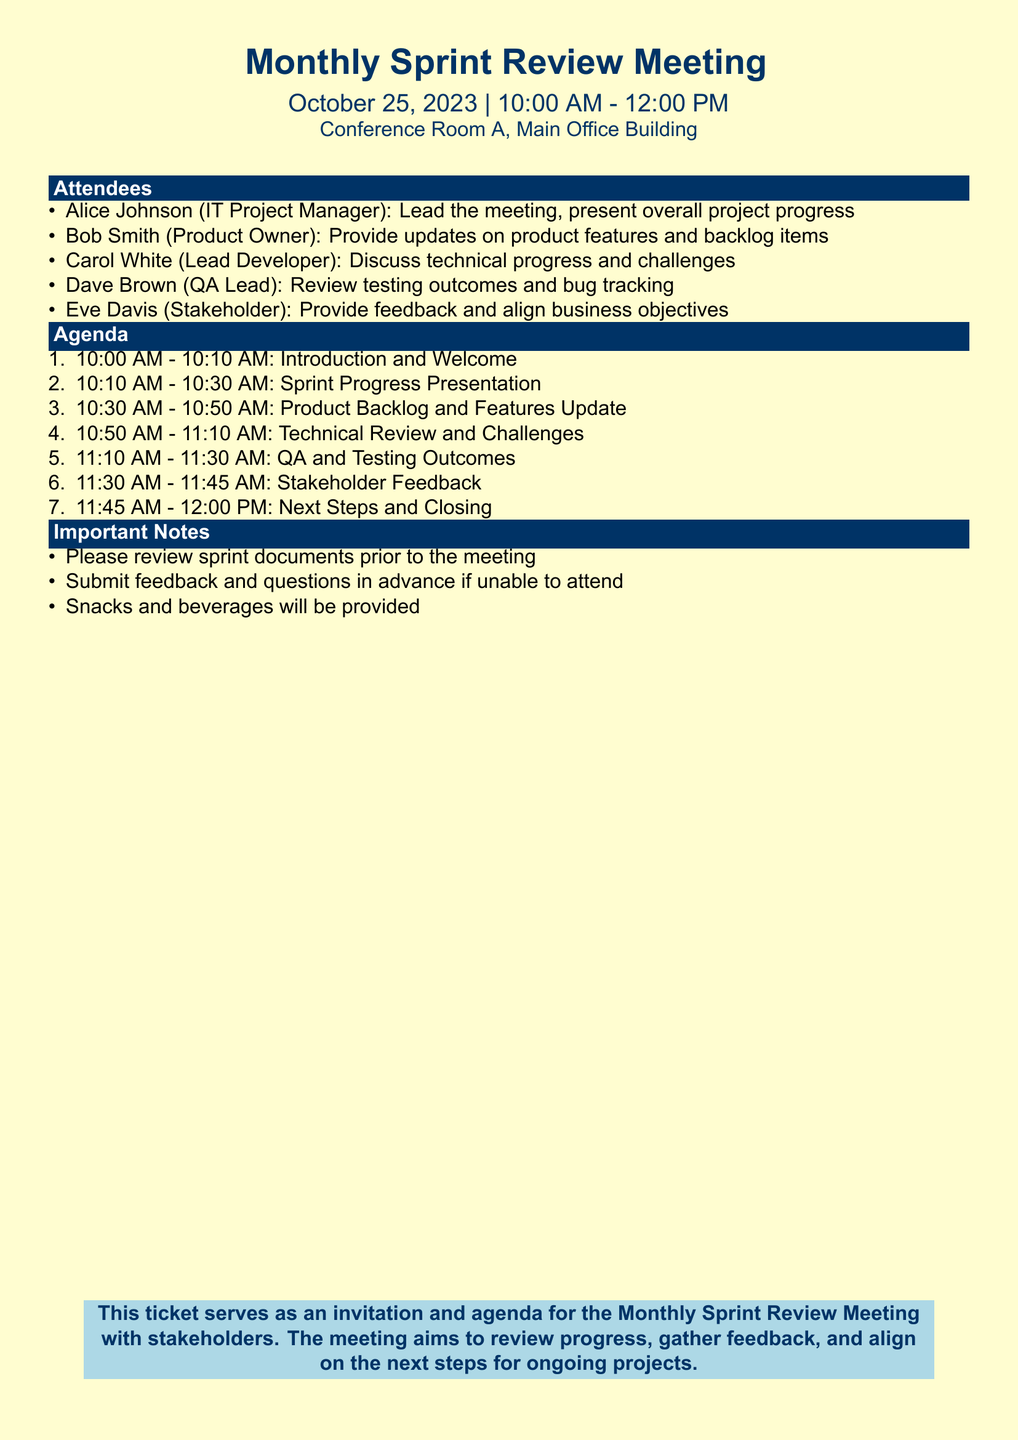What is the date of the meeting? The date is specified in the header of the document, which indicates the meeting is on October 25, 2023.
Answer: October 25, 2023 Who is leading the meeting? The document lists Alice Johnson as the IT Project Manager, who is responsible for leading the meeting.
Answer: Alice Johnson What time does the meeting start? The document states the meeting starts at 10:00 AM.
Answer: 10:00 AM How long is the meeting scheduled to last? The document specifies that the meeting will last for 2 hours, from 10:00 AM to 12:00 PM.
Answer: 2 hours What is the first agenda item? The document outlines the first agenda item as "Introduction and Welcome," which is the first point on the agenda.
Answer: Introduction and Welcome How many attendees are listed in the document? There are five attendees listed in the "Attendees" section of the document.
Answer: Five What feedback is being sought during the meeting? The document indicates that stakeholder feedback will be gathered during the allocated time of the agenda.
Answer: Stakeholder Feedback Which room is the meeting held in? The location of the meeting is specified as Conference Room A in the Main Office Building.
Answer: Conference Room A Are snacks provided? The document mentions that snacks and beverages will be provided during the meeting.
Answer: Yes 